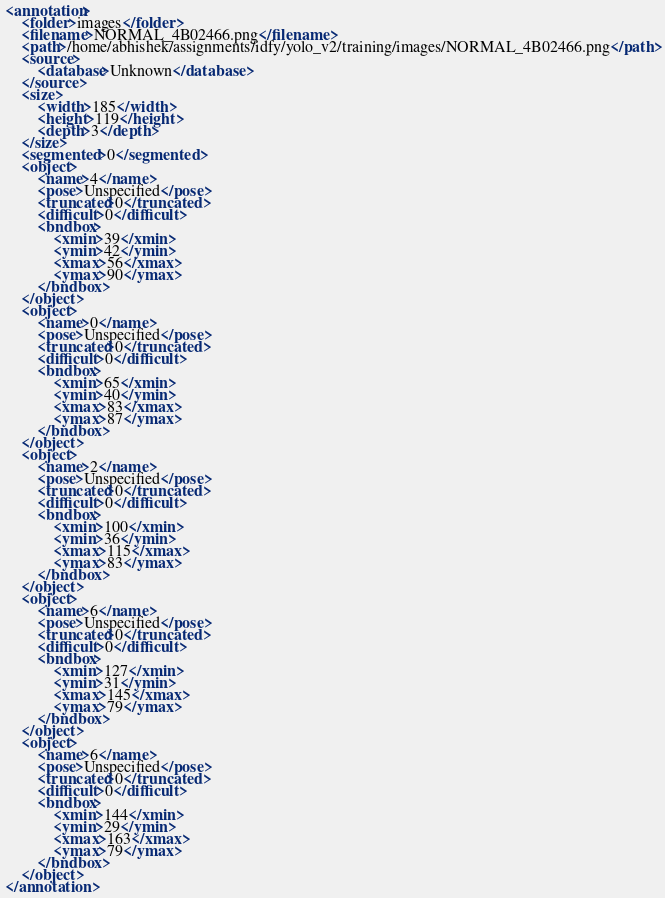Convert code to text. <code><loc_0><loc_0><loc_500><loc_500><_XML_><annotation>
	<folder>images</folder>
	<filename>NORMAL_4B02466.png</filename>
	<path>/home/abhishek/assignments/idfy/yolo_v2/training/images/NORMAL_4B02466.png</path>
	<source>
		<database>Unknown</database>
	</source>
	<size>
		<width>185</width>
		<height>119</height>
		<depth>3</depth>
	</size>
	<segmented>0</segmented>
	<object>
		<name>4</name>
		<pose>Unspecified</pose>
		<truncated>0</truncated>
		<difficult>0</difficult>
		<bndbox>
			<xmin>39</xmin>
			<ymin>42</ymin>
			<xmax>56</xmax>
			<ymax>90</ymax>
		</bndbox>
	</object>
	<object>
		<name>0</name>
		<pose>Unspecified</pose>
		<truncated>0</truncated>
		<difficult>0</difficult>
		<bndbox>
			<xmin>65</xmin>
			<ymin>40</ymin>
			<xmax>83</xmax>
			<ymax>87</ymax>
		</bndbox>
	</object>
	<object>
		<name>2</name>
		<pose>Unspecified</pose>
		<truncated>0</truncated>
		<difficult>0</difficult>
		<bndbox>
			<xmin>100</xmin>
			<ymin>36</ymin>
			<xmax>115</xmax>
			<ymax>83</ymax>
		</bndbox>
	</object>
	<object>
		<name>6</name>
		<pose>Unspecified</pose>
		<truncated>0</truncated>
		<difficult>0</difficult>
		<bndbox>
			<xmin>127</xmin>
			<ymin>31</ymin>
			<xmax>145</xmax>
			<ymax>79</ymax>
		</bndbox>
	</object>
	<object>
		<name>6</name>
		<pose>Unspecified</pose>
		<truncated>0</truncated>
		<difficult>0</difficult>
		<bndbox>
			<xmin>144</xmin>
			<ymin>29</ymin>
			<xmax>163</xmax>
			<ymax>79</ymax>
		</bndbox>
	</object>
</annotation>
</code> 